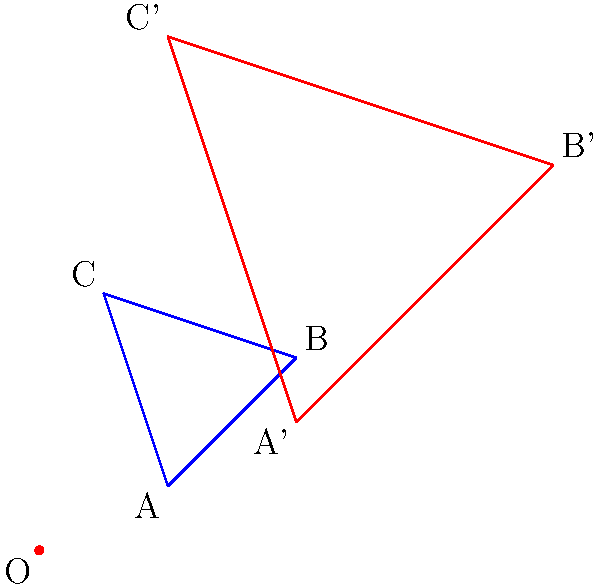As a spokesperson for a major airline company, you're working on adjusting flight path maps for different weather conditions. The original flight path is represented by triangle ABC in the diagram. If severe weather requires expanding the flight path by a factor of 2 from the origin O, what is the area of the new flight path represented by triangle A'B'C' in square units? To solve this problem, we'll follow these steps:

1) First, we need to understand that this is a dilation with a scale factor of 2 from the origin O.

2) In a dilation, the area of the new shape is related to the area of the original shape by the square of the scale factor. In this case:

   $\text{New Area} = (\text{Scale Factor})^2 \times \text{Original Area}$

3) The scale factor is 2, so:

   $\text{New Area} = 2^2 \times \text{Original Area} = 4 \times \text{Original Area}$

4) To find the area of the original triangle ABC, we can use the formula:
   
   $\text{Area} = \frac{1}{2}|\text{det}(\overrightarrow{AB}, \overrightarrow{AC})|$

   Where $\overrightarrow{AB}$ and $\overrightarrow{AC}$ are vectors.

5) $\overrightarrow{AB} = (4-2, 3-1) = (2, 2)$
   $\overrightarrow{AC} = (1-2, 4-1) = (-1, 3)$

6) $\text{det}(\overrightarrow{AB}, \overrightarrow{AC}) = (2)(3) - (2)(-1) = 6 + 2 = 8$

7) $\text{Area of ABC} = \frac{1}{2}|8| = 4$ square units

8) Therefore, the area of A'B'C' is:

   $\text{Area of A'B'C'} = 4 \times 4 = 16$ square units
Answer: 16 square units 